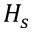Convert formula to latex. <formula><loc_0><loc_0><loc_500><loc_500>H _ { s }</formula> 